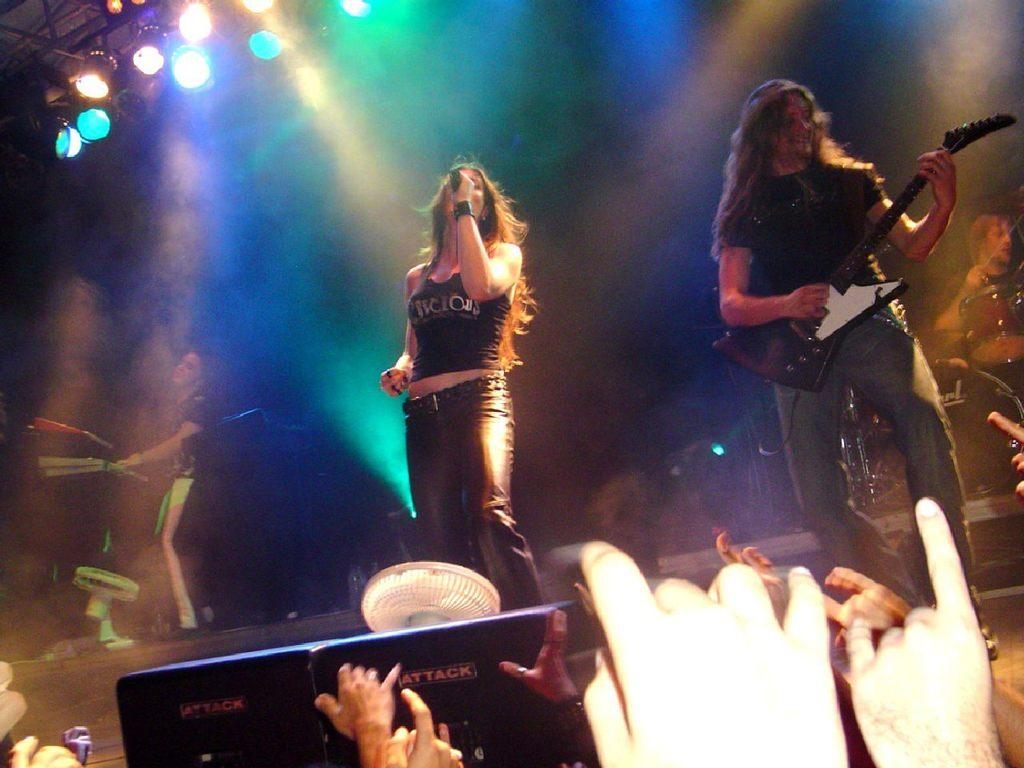How many people are performing in the image? There are four persons in the image. What are the four persons doing in the image? The four persons are performing as a live band. Can you describe the reaction of the people in the image? The audience is present and enjoying the band's performance. What is the weight of the rhythm in the image? There is no specific weight associated with the rhythm in the image, as rhythm is an abstract concept related to the tempo and beat of the music being performed. 